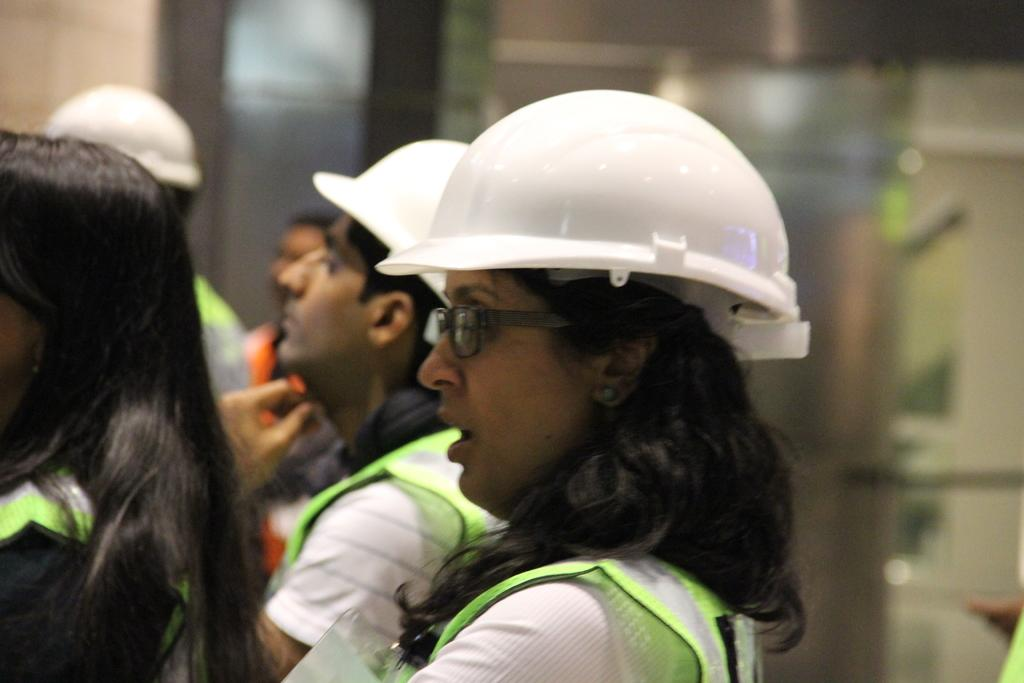How many people are in the image? There is a group of people in the image. What are some of the people wearing? Some of the people are wearing helmets. Can you describe the background of the image? The background of the image is blurry. What type of clover is growing in the background of the image? There is no clover present in the image; the background is blurry. 